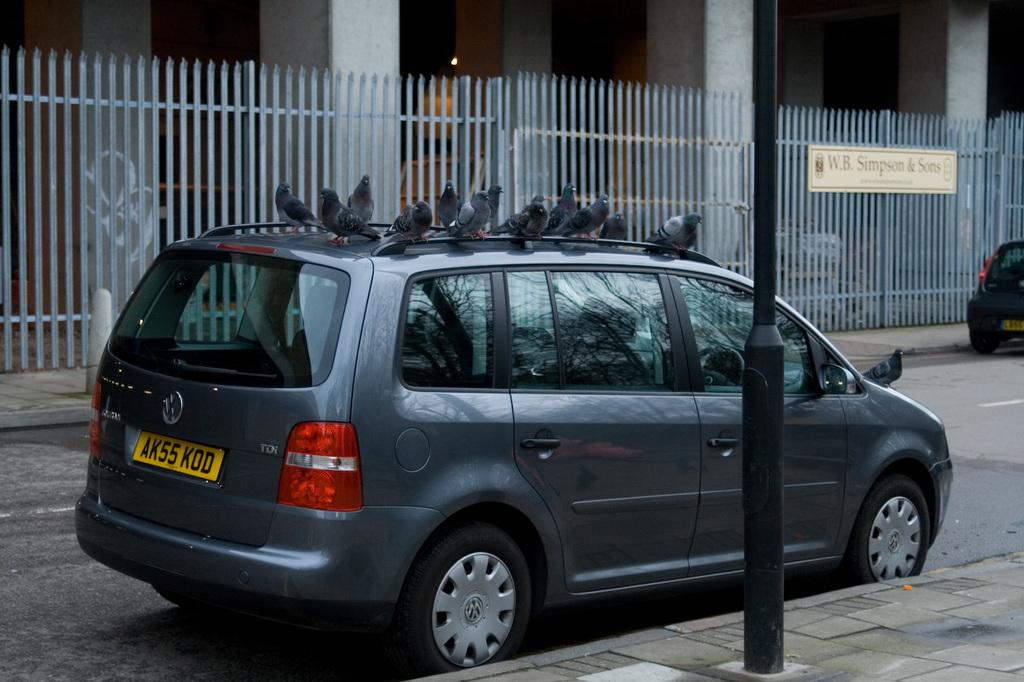<image>
Describe the image concisely. A grey van parked across from a building that houses WB SImpson and Sons. 